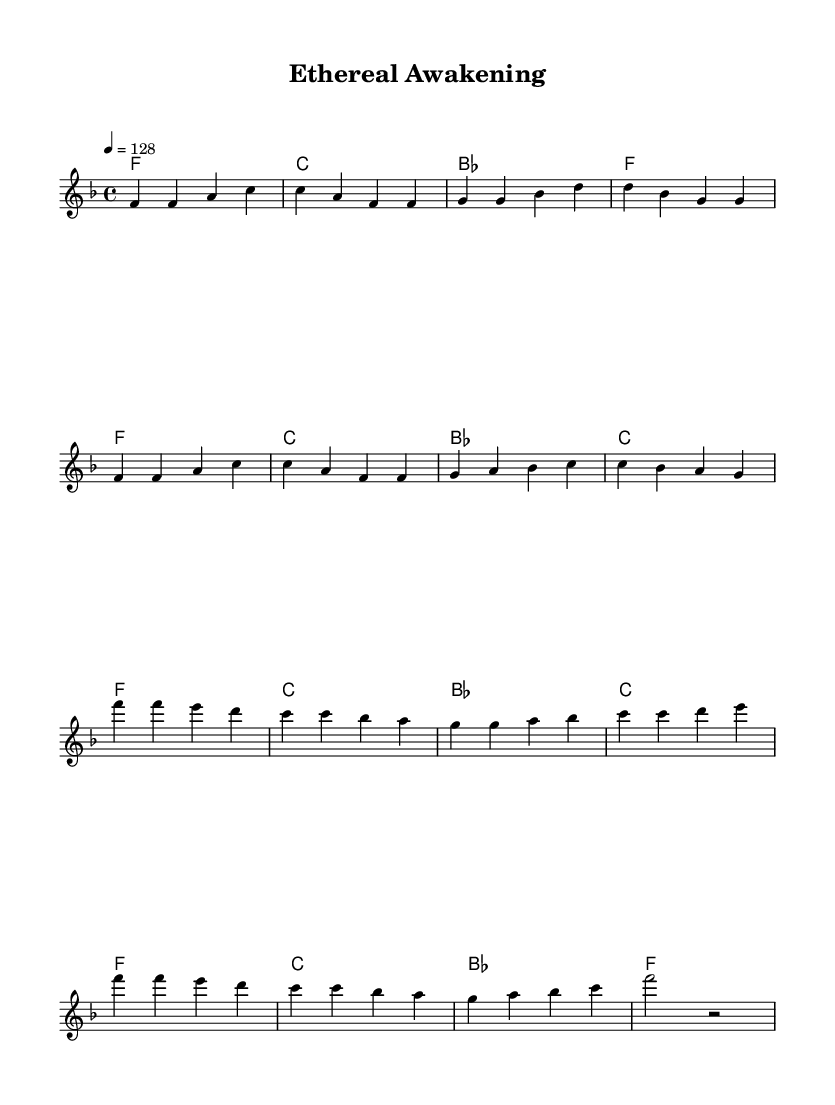What is the key signature of this music? The key signature is F major, which has one flat (B flat). You can identify the key signature at the beginning of the staff, where the flats are indicated.
Answer: F major What is the time signature of this piece? The time signature is 4/4, which is indicated at the beginning of the staff. This means there are four beats in each measure and the quarter note gets one beat.
Answer: 4/4 What is the tempo marking of this music? The tempo marking is 128 BPM, which is indicated above the staff. This indicates the speed of the piece, with a moderate tempo often associated with upbeat tracks.
Answer: 128 How many measures are in the verse section? The verse section contains 8 measures, which can be counted by analyzing the grouping of the notes and the bar lines between them.
Answer: 8 measures What is the structure of the chorus in terms of measures? The chorus consists of 8 measures as well, comprising two repetitions of four measures each. This pattern is common in K-Pop to create catchy and memorable sections.
Answer: 8 measures What type of harmony does this piece use? This piece uses chord harmonies primarily in triads, which means each chord is built from three notes. The harmonic progression shown in the score supports the catchy melody typical of K-Pop tracks.
Answer: Triads How does the musical theme relate to spiritual concepts? The lyrical content and melodic structure focus on themes of awakening and enlightenment, often expressed through upbeat tempos and harmonies that evoke a sense of joy and liberation, reflecting the genre's trend toward introspective yet uplifting messages.
Answer: Awakening 